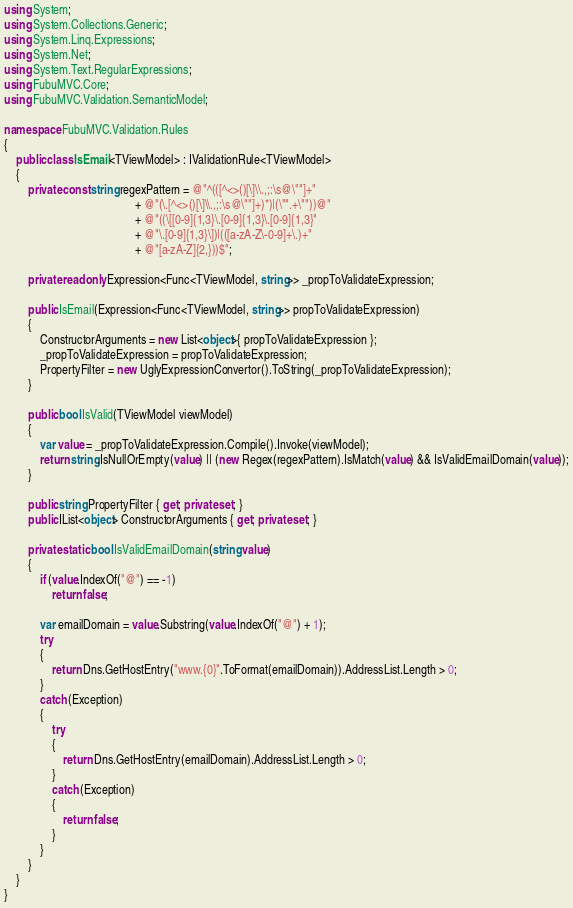<code> <loc_0><loc_0><loc_500><loc_500><_C#_>using System;
using System.Collections.Generic;
using System.Linq.Expressions;
using System.Net;
using System.Text.RegularExpressions;
using FubuMVC.Core;
using FubuMVC.Validation.SemanticModel;

namespace FubuMVC.Validation.Rules
{
    public class IsEmail<TViewModel> : IValidationRule<TViewModel> 
    {
        private const string regexPattern = @"^(([^<>()[\]\\.,;:\s@\""]+"
                                            + @"(\.[^<>()[\]\\.,;:\s@\""]+)*)|(\"".+\""))@"
                                            + @"((\[[0-9]{1,3}\.[0-9]{1,3}\.[0-9]{1,3}"
                                            + @"\.[0-9]{1,3}\])|(([a-zA-Z\-0-9]+\.)+"
                                            + @"[a-zA-Z]{2,}))$";

        private readonly Expression<Func<TViewModel, string>> _propToValidateExpression;

        public IsEmail(Expression<Func<TViewModel, string>> propToValidateExpression)
        {
            ConstructorArguments = new List<object>{ propToValidateExpression };
            _propToValidateExpression = propToValidateExpression;
            PropertyFilter = new UglyExpressionConvertor().ToString(_propToValidateExpression);
        }

        public bool IsValid(TViewModel viewModel)
        {
            var value = _propToValidateExpression.Compile().Invoke(viewModel);
            return string.IsNullOrEmpty(value) || (new Regex(regexPattern).IsMatch(value) && IsValidEmailDomain(value));
        }

        public string PropertyFilter { get; private set; }
        public IList<object> ConstructorArguments { get; private set; }

        private static bool IsValidEmailDomain(string value)
        {
            if (value.IndexOf("@") == -1)
                return false;

            var emailDomain = value.Substring(value.IndexOf("@") + 1);
            try
            {
                return Dns.GetHostEntry("www.{0}".ToFormat(emailDomain)).AddressList.Length > 0;
            }
            catch (Exception)
            {
                try
                {
                    return Dns.GetHostEntry(emailDomain).AddressList.Length > 0;
                }
                catch (Exception)
                {
                    return false;
                }
            }
        }
    }
}</code> 